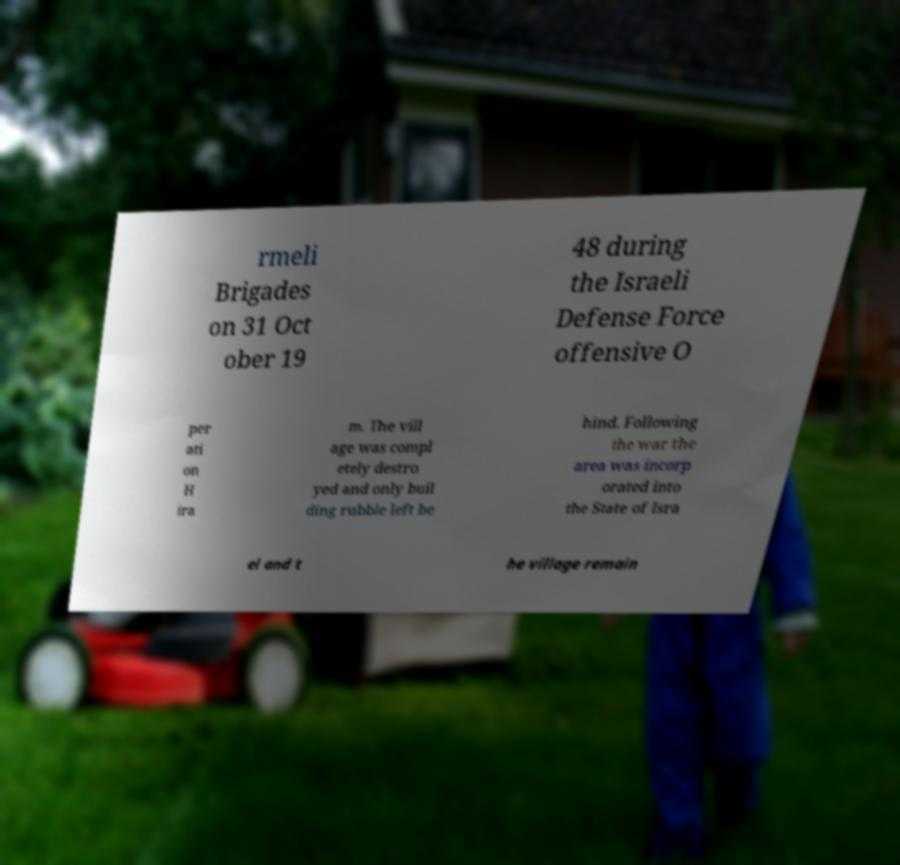Could you assist in decoding the text presented in this image and type it out clearly? rmeli Brigades on 31 Oct ober 19 48 during the Israeli Defense Force offensive O per ati on H ira m. The vill age was compl etely destro yed and only buil ding rubble left be hind. Following the war the area was incorp orated into the State of Isra el and t he village remain 